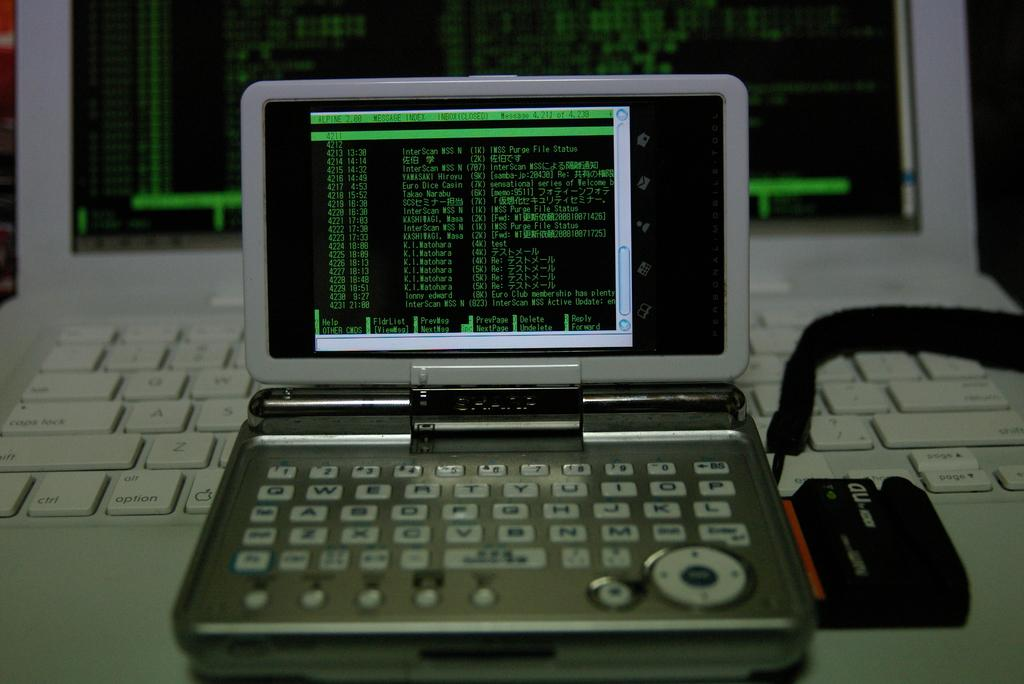<image>
Offer a succinct explanation of the picture presented. A computer screen shows code that says Euro club Membership has plenty/ 